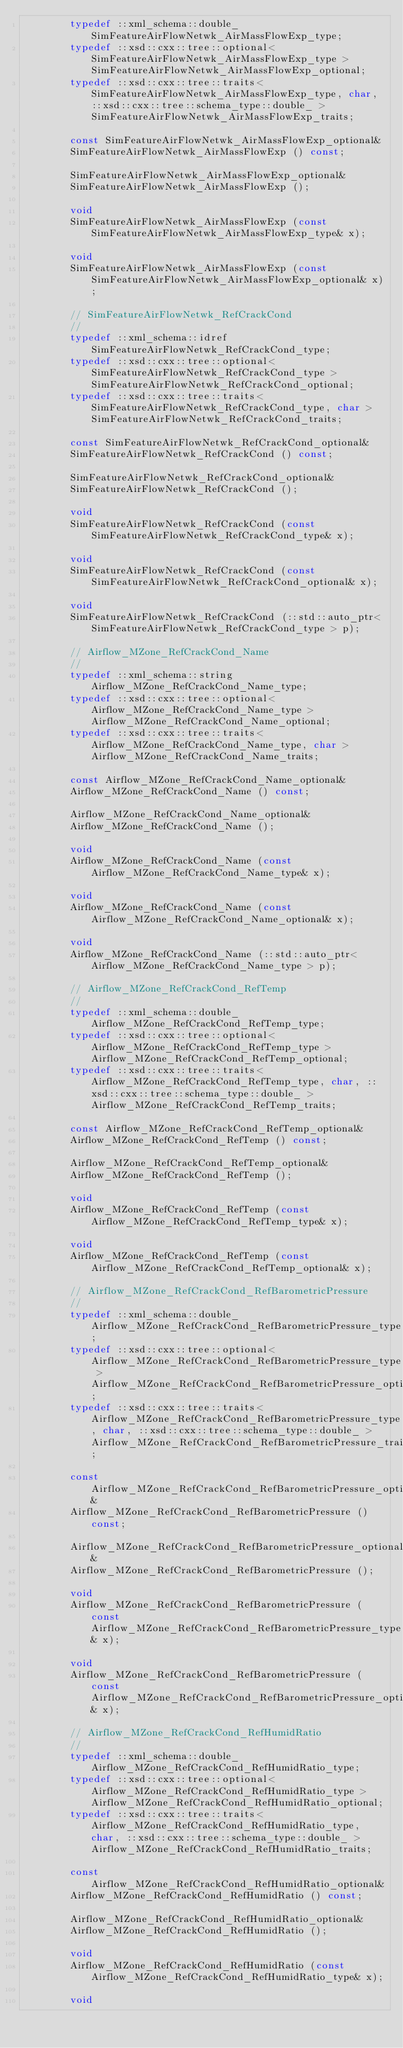<code> <loc_0><loc_0><loc_500><loc_500><_C++_>        typedef ::xml_schema::double_ SimFeatureAirFlowNetwk_AirMassFlowExp_type;
        typedef ::xsd::cxx::tree::optional< SimFeatureAirFlowNetwk_AirMassFlowExp_type > SimFeatureAirFlowNetwk_AirMassFlowExp_optional;
        typedef ::xsd::cxx::tree::traits< SimFeatureAirFlowNetwk_AirMassFlowExp_type, char, ::xsd::cxx::tree::schema_type::double_ > SimFeatureAirFlowNetwk_AirMassFlowExp_traits;

        const SimFeatureAirFlowNetwk_AirMassFlowExp_optional&
        SimFeatureAirFlowNetwk_AirMassFlowExp () const;

        SimFeatureAirFlowNetwk_AirMassFlowExp_optional&
        SimFeatureAirFlowNetwk_AirMassFlowExp ();

        void
        SimFeatureAirFlowNetwk_AirMassFlowExp (const SimFeatureAirFlowNetwk_AirMassFlowExp_type& x);

        void
        SimFeatureAirFlowNetwk_AirMassFlowExp (const SimFeatureAirFlowNetwk_AirMassFlowExp_optional& x);

        // SimFeatureAirFlowNetwk_RefCrackCond
        //
        typedef ::xml_schema::idref SimFeatureAirFlowNetwk_RefCrackCond_type;
        typedef ::xsd::cxx::tree::optional< SimFeatureAirFlowNetwk_RefCrackCond_type > SimFeatureAirFlowNetwk_RefCrackCond_optional;
        typedef ::xsd::cxx::tree::traits< SimFeatureAirFlowNetwk_RefCrackCond_type, char > SimFeatureAirFlowNetwk_RefCrackCond_traits;

        const SimFeatureAirFlowNetwk_RefCrackCond_optional&
        SimFeatureAirFlowNetwk_RefCrackCond () const;

        SimFeatureAirFlowNetwk_RefCrackCond_optional&
        SimFeatureAirFlowNetwk_RefCrackCond ();

        void
        SimFeatureAirFlowNetwk_RefCrackCond (const SimFeatureAirFlowNetwk_RefCrackCond_type& x);

        void
        SimFeatureAirFlowNetwk_RefCrackCond (const SimFeatureAirFlowNetwk_RefCrackCond_optional& x);

        void
        SimFeatureAirFlowNetwk_RefCrackCond (::std::auto_ptr< SimFeatureAirFlowNetwk_RefCrackCond_type > p);

        // Airflow_MZone_RefCrackCond_Name
        //
        typedef ::xml_schema::string Airflow_MZone_RefCrackCond_Name_type;
        typedef ::xsd::cxx::tree::optional< Airflow_MZone_RefCrackCond_Name_type > Airflow_MZone_RefCrackCond_Name_optional;
        typedef ::xsd::cxx::tree::traits< Airflow_MZone_RefCrackCond_Name_type, char > Airflow_MZone_RefCrackCond_Name_traits;

        const Airflow_MZone_RefCrackCond_Name_optional&
        Airflow_MZone_RefCrackCond_Name () const;

        Airflow_MZone_RefCrackCond_Name_optional&
        Airflow_MZone_RefCrackCond_Name ();

        void
        Airflow_MZone_RefCrackCond_Name (const Airflow_MZone_RefCrackCond_Name_type& x);

        void
        Airflow_MZone_RefCrackCond_Name (const Airflow_MZone_RefCrackCond_Name_optional& x);

        void
        Airflow_MZone_RefCrackCond_Name (::std::auto_ptr< Airflow_MZone_RefCrackCond_Name_type > p);

        // Airflow_MZone_RefCrackCond_RefTemp
        //
        typedef ::xml_schema::double_ Airflow_MZone_RefCrackCond_RefTemp_type;
        typedef ::xsd::cxx::tree::optional< Airflow_MZone_RefCrackCond_RefTemp_type > Airflow_MZone_RefCrackCond_RefTemp_optional;
        typedef ::xsd::cxx::tree::traits< Airflow_MZone_RefCrackCond_RefTemp_type, char, ::xsd::cxx::tree::schema_type::double_ > Airflow_MZone_RefCrackCond_RefTemp_traits;

        const Airflow_MZone_RefCrackCond_RefTemp_optional&
        Airflow_MZone_RefCrackCond_RefTemp () const;

        Airflow_MZone_RefCrackCond_RefTemp_optional&
        Airflow_MZone_RefCrackCond_RefTemp ();

        void
        Airflow_MZone_RefCrackCond_RefTemp (const Airflow_MZone_RefCrackCond_RefTemp_type& x);

        void
        Airflow_MZone_RefCrackCond_RefTemp (const Airflow_MZone_RefCrackCond_RefTemp_optional& x);

        // Airflow_MZone_RefCrackCond_RefBarometricPressure
        //
        typedef ::xml_schema::double_ Airflow_MZone_RefCrackCond_RefBarometricPressure_type;
        typedef ::xsd::cxx::tree::optional< Airflow_MZone_RefCrackCond_RefBarometricPressure_type > Airflow_MZone_RefCrackCond_RefBarometricPressure_optional;
        typedef ::xsd::cxx::tree::traits< Airflow_MZone_RefCrackCond_RefBarometricPressure_type, char, ::xsd::cxx::tree::schema_type::double_ > Airflow_MZone_RefCrackCond_RefBarometricPressure_traits;

        const Airflow_MZone_RefCrackCond_RefBarometricPressure_optional&
        Airflow_MZone_RefCrackCond_RefBarometricPressure () const;

        Airflow_MZone_RefCrackCond_RefBarometricPressure_optional&
        Airflow_MZone_RefCrackCond_RefBarometricPressure ();

        void
        Airflow_MZone_RefCrackCond_RefBarometricPressure (const Airflow_MZone_RefCrackCond_RefBarometricPressure_type& x);

        void
        Airflow_MZone_RefCrackCond_RefBarometricPressure (const Airflow_MZone_RefCrackCond_RefBarometricPressure_optional& x);

        // Airflow_MZone_RefCrackCond_RefHumidRatio
        //
        typedef ::xml_schema::double_ Airflow_MZone_RefCrackCond_RefHumidRatio_type;
        typedef ::xsd::cxx::tree::optional< Airflow_MZone_RefCrackCond_RefHumidRatio_type > Airflow_MZone_RefCrackCond_RefHumidRatio_optional;
        typedef ::xsd::cxx::tree::traits< Airflow_MZone_RefCrackCond_RefHumidRatio_type, char, ::xsd::cxx::tree::schema_type::double_ > Airflow_MZone_RefCrackCond_RefHumidRatio_traits;

        const Airflow_MZone_RefCrackCond_RefHumidRatio_optional&
        Airflow_MZone_RefCrackCond_RefHumidRatio () const;

        Airflow_MZone_RefCrackCond_RefHumidRatio_optional&
        Airflow_MZone_RefCrackCond_RefHumidRatio ();

        void
        Airflow_MZone_RefCrackCond_RefHumidRatio (const Airflow_MZone_RefCrackCond_RefHumidRatio_type& x);

        void</code> 